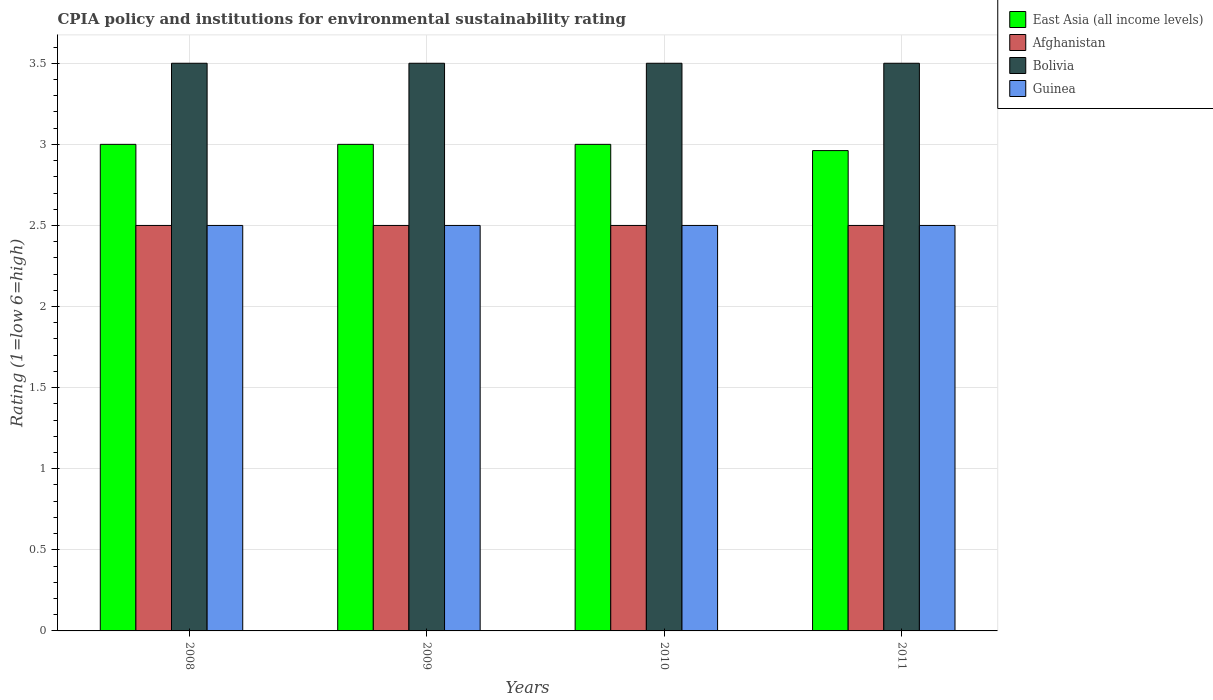How many different coloured bars are there?
Keep it short and to the point. 4. How many groups of bars are there?
Keep it short and to the point. 4. Are the number of bars per tick equal to the number of legend labels?
Ensure brevity in your answer.  Yes. How many bars are there on the 4th tick from the right?
Your response must be concise. 4. What is the label of the 2nd group of bars from the left?
Provide a succinct answer. 2009. In how many cases, is the number of bars for a given year not equal to the number of legend labels?
Ensure brevity in your answer.  0. What is the CPIA rating in Bolivia in 2010?
Give a very brief answer. 3.5. Across all years, what is the minimum CPIA rating in East Asia (all income levels)?
Keep it short and to the point. 2.96. In which year was the CPIA rating in East Asia (all income levels) maximum?
Keep it short and to the point. 2008. In which year was the CPIA rating in Bolivia minimum?
Your answer should be compact. 2008. What is the total CPIA rating in Guinea in the graph?
Offer a very short reply. 10. What is the difference between the CPIA rating in Bolivia in 2008 and the CPIA rating in Guinea in 2010?
Your response must be concise. 1. What is the average CPIA rating in East Asia (all income levels) per year?
Offer a terse response. 2.99. In the year 2009, what is the difference between the CPIA rating in Afghanistan and CPIA rating in East Asia (all income levels)?
Your answer should be very brief. -0.5. What is the ratio of the CPIA rating in Guinea in 2008 to that in 2011?
Ensure brevity in your answer.  1. What is the difference between the highest and the second highest CPIA rating in East Asia (all income levels)?
Your response must be concise. 0. What is the difference between the highest and the lowest CPIA rating in Bolivia?
Provide a short and direct response. 0. Is it the case that in every year, the sum of the CPIA rating in Afghanistan and CPIA rating in East Asia (all income levels) is greater than the sum of CPIA rating in Bolivia and CPIA rating in Guinea?
Provide a succinct answer. No. What does the 2nd bar from the right in 2010 represents?
Provide a short and direct response. Bolivia. Does the graph contain grids?
Provide a succinct answer. Yes. How many legend labels are there?
Provide a succinct answer. 4. How are the legend labels stacked?
Your answer should be very brief. Vertical. What is the title of the graph?
Provide a short and direct response. CPIA policy and institutions for environmental sustainability rating. What is the label or title of the X-axis?
Your response must be concise. Years. What is the Rating (1=low 6=high) of Bolivia in 2008?
Offer a terse response. 3.5. What is the Rating (1=low 6=high) in Guinea in 2008?
Make the answer very short. 2.5. What is the Rating (1=low 6=high) in East Asia (all income levels) in 2009?
Offer a terse response. 3. What is the Rating (1=low 6=high) in East Asia (all income levels) in 2011?
Your response must be concise. 2.96. Across all years, what is the maximum Rating (1=low 6=high) in East Asia (all income levels)?
Your answer should be compact. 3. Across all years, what is the maximum Rating (1=low 6=high) of Afghanistan?
Provide a short and direct response. 2.5. Across all years, what is the minimum Rating (1=low 6=high) of East Asia (all income levels)?
Ensure brevity in your answer.  2.96. What is the total Rating (1=low 6=high) in East Asia (all income levels) in the graph?
Keep it short and to the point. 11.96. What is the total Rating (1=low 6=high) of Afghanistan in the graph?
Offer a terse response. 10. What is the total Rating (1=low 6=high) of Bolivia in the graph?
Make the answer very short. 14. What is the difference between the Rating (1=low 6=high) in East Asia (all income levels) in 2008 and that in 2009?
Provide a short and direct response. 0. What is the difference between the Rating (1=low 6=high) of Bolivia in 2008 and that in 2009?
Your answer should be very brief. 0. What is the difference between the Rating (1=low 6=high) in Afghanistan in 2008 and that in 2010?
Offer a very short reply. 0. What is the difference between the Rating (1=low 6=high) of East Asia (all income levels) in 2008 and that in 2011?
Make the answer very short. 0.04. What is the difference between the Rating (1=low 6=high) of Guinea in 2008 and that in 2011?
Provide a succinct answer. 0. What is the difference between the Rating (1=low 6=high) in East Asia (all income levels) in 2009 and that in 2010?
Your answer should be very brief. 0. What is the difference between the Rating (1=low 6=high) of Guinea in 2009 and that in 2010?
Your answer should be compact. 0. What is the difference between the Rating (1=low 6=high) in East Asia (all income levels) in 2009 and that in 2011?
Give a very brief answer. 0.04. What is the difference between the Rating (1=low 6=high) in Afghanistan in 2009 and that in 2011?
Offer a very short reply. 0. What is the difference between the Rating (1=low 6=high) of Bolivia in 2009 and that in 2011?
Offer a very short reply. 0. What is the difference between the Rating (1=low 6=high) in East Asia (all income levels) in 2010 and that in 2011?
Your answer should be very brief. 0.04. What is the difference between the Rating (1=low 6=high) in Afghanistan in 2010 and that in 2011?
Your answer should be compact. 0. What is the difference between the Rating (1=low 6=high) in Bolivia in 2010 and that in 2011?
Your response must be concise. 0. What is the difference between the Rating (1=low 6=high) of Guinea in 2010 and that in 2011?
Your response must be concise. 0. What is the difference between the Rating (1=low 6=high) in East Asia (all income levels) in 2008 and the Rating (1=low 6=high) in Afghanistan in 2009?
Your answer should be compact. 0.5. What is the difference between the Rating (1=low 6=high) of East Asia (all income levels) in 2008 and the Rating (1=low 6=high) of Bolivia in 2009?
Offer a terse response. -0.5. What is the difference between the Rating (1=low 6=high) in Afghanistan in 2008 and the Rating (1=low 6=high) in Bolivia in 2009?
Keep it short and to the point. -1. What is the difference between the Rating (1=low 6=high) of Afghanistan in 2008 and the Rating (1=low 6=high) of Guinea in 2009?
Ensure brevity in your answer.  0. What is the difference between the Rating (1=low 6=high) in Bolivia in 2008 and the Rating (1=low 6=high) in Guinea in 2009?
Keep it short and to the point. 1. What is the difference between the Rating (1=low 6=high) in Bolivia in 2008 and the Rating (1=low 6=high) in Guinea in 2010?
Make the answer very short. 1. What is the difference between the Rating (1=low 6=high) of East Asia (all income levels) in 2009 and the Rating (1=low 6=high) of Afghanistan in 2010?
Make the answer very short. 0.5. What is the difference between the Rating (1=low 6=high) of East Asia (all income levels) in 2009 and the Rating (1=low 6=high) of Bolivia in 2010?
Make the answer very short. -0.5. What is the difference between the Rating (1=low 6=high) in Bolivia in 2009 and the Rating (1=low 6=high) in Guinea in 2010?
Your answer should be compact. 1. What is the difference between the Rating (1=low 6=high) in East Asia (all income levels) in 2009 and the Rating (1=low 6=high) in Afghanistan in 2011?
Offer a terse response. 0.5. What is the difference between the Rating (1=low 6=high) of East Asia (all income levels) in 2009 and the Rating (1=low 6=high) of Bolivia in 2011?
Ensure brevity in your answer.  -0.5. What is the difference between the Rating (1=low 6=high) in East Asia (all income levels) in 2009 and the Rating (1=low 6=high) in Guinea in 2011?
Offer a very short reply. 0.5. What is the difference between the Rating (1=low 6=high) in Afghanistan in 2009 and the Rating (1=low 6=high) in Bolivia in 2011?
Provide a succinct answer. -1. What is the difference between the Rating (1=low 6=high) in Afghanistan in 2009 and the Rating (1=low 6=high) in Guinea in 2011?
Keep it short and to the point. 0. What is the difference between the Rating (1=low 6=high) in East Asia (all income levels) in 2010 and the Rating (1=low 6=high) in Guinea in 2011?
Offer a terse response. 0.5. What is the difference between the Rating (1=low 6=high) of Afghanistan in 2010 and the Rating (1=low 6=high) of Bolivia in 2011?
Keep it short and to the point. -1. What is the average Rating (1=low 6=high) of East Asia (all income levels) per year?
Make the answer very short. 2.99. What is the average Rating (1=low 6=high) of Bolivia per year?
Your answer should be very brief. 3.5. In the year 2008, what is the difference between the Rating (1=low 6=high) in East Asia (all income levels) and Rating (1=low 6=high) in Afghanistan?
Keep it short and to the point. 0.5. In the year 2008, what is the difference between the Rating (1=low 6=high) in East Asia (all income levels) and Rating (1=low 6=high) in Bolivia?
Your response must be concise. -0.5. In the year 2008, what is the difference between the Rating (1=low 6=high) of East Asia (all income levels) and Rating (1=low 6=high) of Guinea?
Ensure brevity in your answer.  0.5. In the year 2008, what is the difference between the Rating (1=low 6=high) in Afghanistan and Rating (1=low 6=high) in Bolivia?
Provide a short and direct response. -1. In the year 2008, what is the difference between the Rating (1=low 6=high) in Afghanistan and Rating (1=low 6=high) in Guinea?
Your response must be concise. 0. In the year 2009, what is the difference between the Rating (1=low 6=high) in East Asia (all income levels) and Rating (1=low 6=high) in Bolivia?
Offer a terse response. -0.5. In the year 2009, what is the difference between the Rating (1=low 6=high) in Afghanistan and Rating (1=low 6=high) in Guinea?
Your response must be concise. 0. In the year 2009, what is the difference between the Rating (1=low 6=high) of Bolivia and Rating (1=low 6=high) of Guinea?
Offer a very short reply. 1. In the year 2010, what is the difference between the Rating (1=low 6=high) of East Asia (all income levels) and Rating (1=low 6=high) of Afghanistan?
Your answer should be compact. 0.5. In the year 2010, what is the difference between the Rating (1=low 6=high) in Afghanistan and Rating (1=low 6=high) in Bolivia?
Provide a succinct answer. -1. In the year 2010, what is the difference between the Rating (1=low 6=high) of Afghanistan and Rating (1=low 6=high) of Guinea?
Give a very brief answer. 0. In the year 2011, what is the difference between the Rating (1=low 6=high) of East Asia (all income levels) and Rating (1=low 6=high) of Afghanistan?
Ensure brevity in your answer.  0.46. In the year 2011, what is the difference between the Rating (1=low 6=high) in East Asia (all income levels) and Rating (1=low 6=high) in Bolivia?
Keep it short and to the point. -0.54. In the year 2011, what is the difference between the Rating (1=low 6=high) of East Asia (all income levels) and Rating (1=low 6=high) of Guinea?
Provide a succinct answer. 0.46. In the year 2011, what is the difference between the Rating (1=low 6=high) in Afghanistan and Rating (1=low 6=high) in Bolivia?
Ensure brevity in your answer.  -1. What is the ratio of the Rating (1=low 6=high) in Afghanistan in 2008 to that in 2009?
Your answer should be compact. 1. What is the ratio of the Rating (1=low 6=high) in Bolivia in 2008 to that in 2010?
Keep it short and to the point. 1. What is the ratio of the Rating (1=low 6=high) in Guinea in 2008 to that in 2010?
Provide a short and direct response. 1. What is the ratio of the Rating (1=low 6=high) in East Asia (all income levels) in 2008 to that in 2011?
Offer a very short reply. 1.01. What is the ratio of the Rating (1=low 6=high) of Bolivia in 2009 to that in 2010?
Your answer should be compact. 1. What is the ratio of the Rating (1=low 6=high) of Guinea in 2009 to that in 2010?
Provide a short and direct response. 1. What is the ratio of the Rating (1=low 6=high) of Bolivia in 2009 to that in 2011?
Ensure brevity in your answer.  1. What is the ratio of the Rating (1=low 6=high) in Guinea in 2009 to that in 2011?
Ensure brevity in your answer.  1. What is the ratio of the Rating (1=low 6=high) of Afghanistan in 2010 to that in 2011?
Make the answer very short. 1. What is the ratio of the Rating (1=low 6=high) in Bolivia in 2010 to that in 2011?
Offer a terse response. 1. What is the ratio of the Rating (1=low 6=high) of Guinea in 2010 to that in 2011?
Keep it short and to the point. 1. What is the difference between the highest and the second highest Rating (1=low 6=high) in Guinea?
Provide a succinct answer. 0. What is the difference between the highest and the lowest Rating (1=low 6=high) of East Asia (all income levels)?
Provide a short and direct response. 0.04. What is the difference between the highest and the lowest Rating (1=low 6=high) of Afghanistan?
Make the answer very short. 0. What is the difference between the highest and the lowest Rating (1=low 6=high) of Guinea?
Your answer should be compact. 0. 